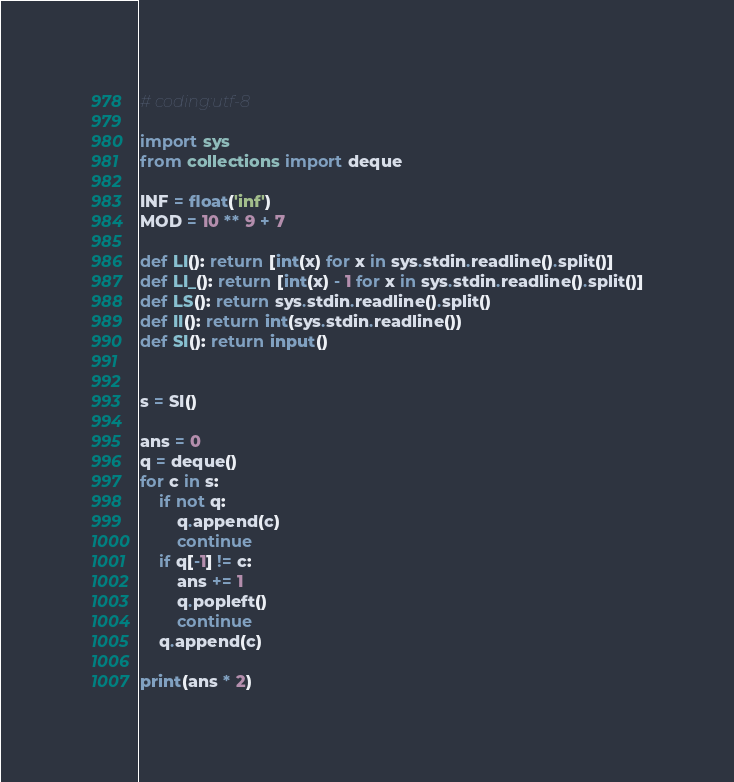<code> <loc_0><loc_0><loc_500><loc_500><_Python_># coding:utf-8

import sys
from collections import deque

INF = float('inf')
MOD = 10 ** 9 + 7

def LI(): return [int(x) for x in sys.stdin.readline().split()]
def LI_(): return [int(x) - 1 for x in sys.stdin.readline().split()]
def LS(): return sys.stdin.readline().split()
def II(): return int(sys.stdin.readline())
def SI(): return input()


s = SI()

ans = 0
q = deque()
for c in s:
    if not q:
        q.append(c)
        continue
    if q[-1] != c:
        ans += 1
        q.popleft()
        continue
    q.append(c)

print(ans * 2)
</code> 